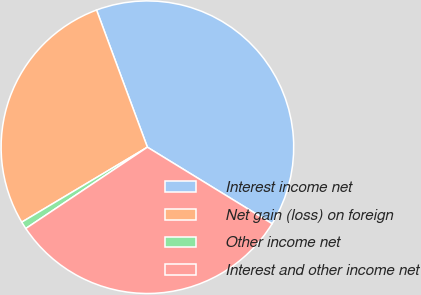Convert chart. <chart><loc_0><loc_0><loc_500><loc_500><pie_chart><fcel>Interest income net<fcel>Net gain (loss) on foreign<fcel>Other income net<fcel>Interest and other income net<nl><fcel>39.41%<fcel>27.91%<fcel>0.82%<fcel>31.86%<nl></chart> 